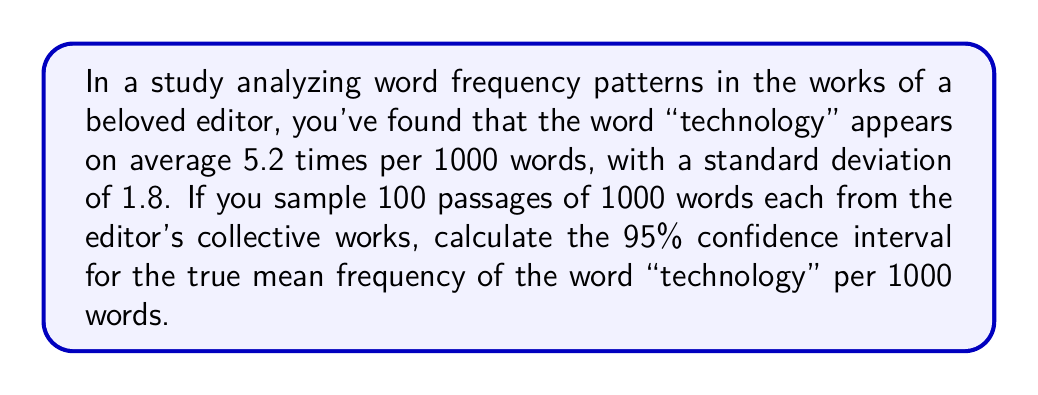Solve this math problem. To calculate the confidence interval, we'll follow these steps:

1. Identify the given information:
   - Sample mean ($\bar{x}$) = 5.2 occurrences per 1000 words
   - Sample standard deviation ($s$) = 1.8
   - Sample size ($n$) = 100
   - Confidence level = 95%

2. Determine the critical value:
   For a 95% confidence interval, we use the z-score of 1.96.

3. Calculate the standard error of the mean:
   $$SE = \frac{s}{\sqrt{n}} = \frac{1.8}{\sqrt{100}} = 0.18$$

4. Calculate the margin of error:
   $$ME = z \cdot SE = 1.96 \cdot 0.18 = 0.3528$$

5. Compute the confidence interval:
   Lower bound: $\bar{x} - ME = 5.2 - 0.3528 = 4.8472$
   Upper bound: $\bar{x} + ME = 5.2 + 0.3528 = 5.5528$

Therefore, the 95% confidence interval is (4.8472, 5.5528) occurrences per 1000 words.
Answer: (4.8472, 5.5528) 